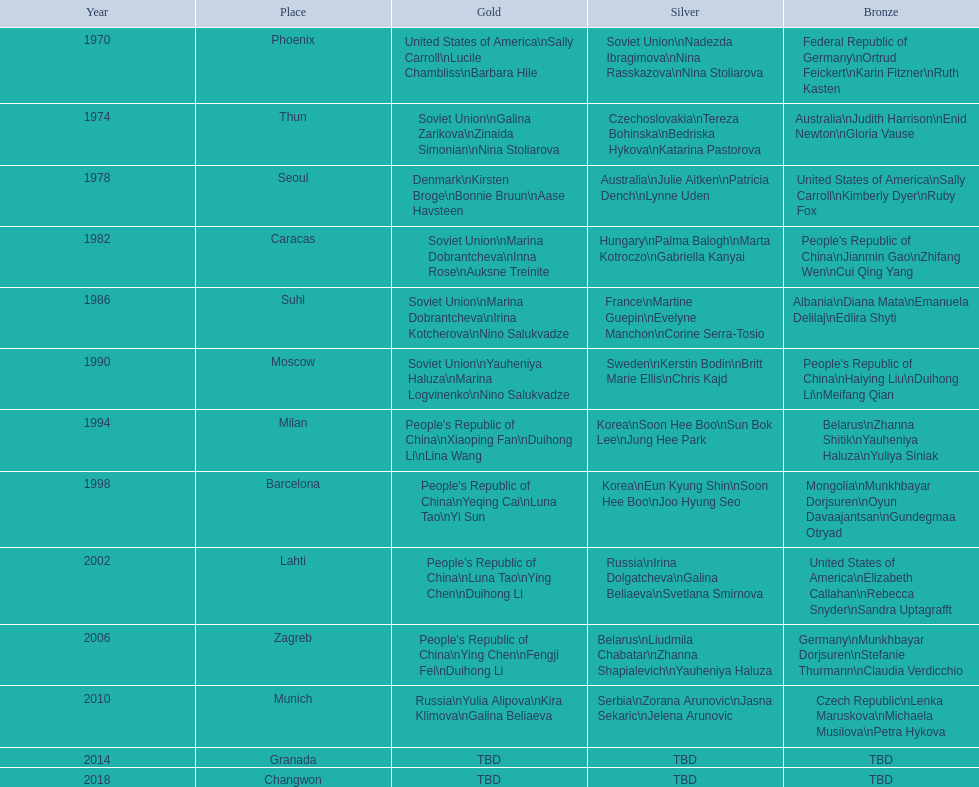In the women's 25-meter pistol world championship, how many times did the soviet union achieve victory? 4. 